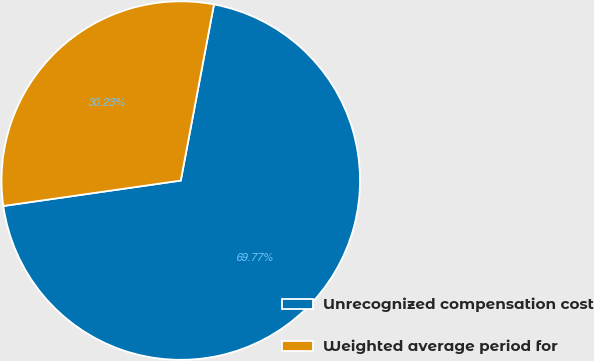<chart> <loc_0><loc_0><loc_500><loc_500><pie_chart><fcel>Unrecognized compensation cost<fcel>Weighted average period for<nl><fcel>69.77%<fcel>30.23%<nl></chart> 